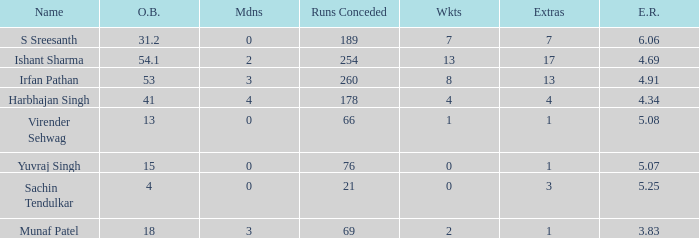Specify the aggregate amount of wickets for yuvraj singh. 1.0. 